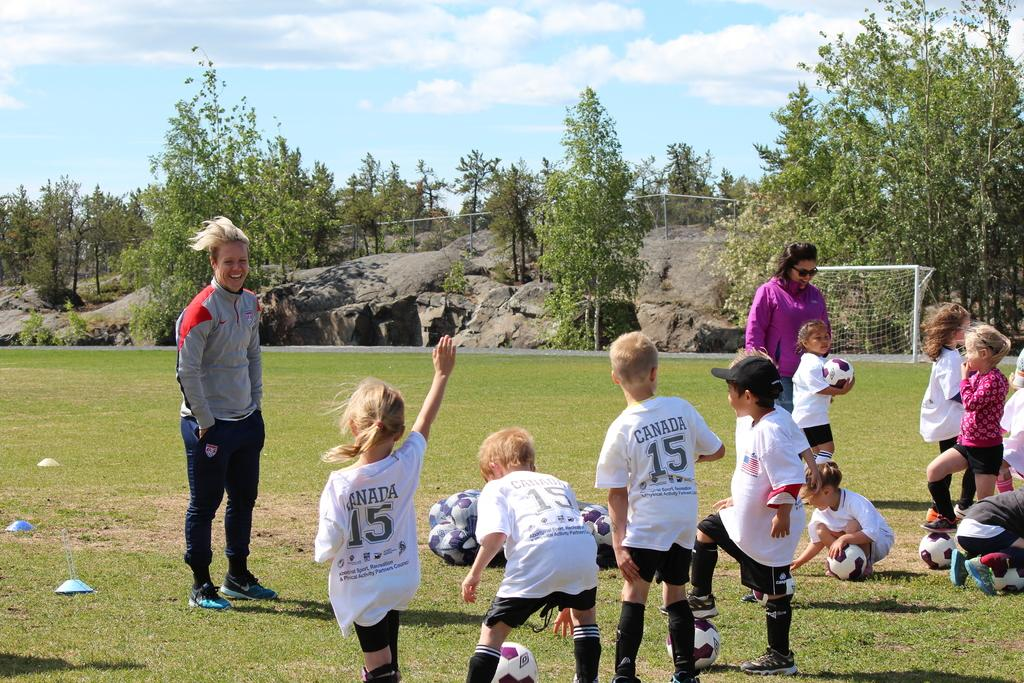How many people are in the group visible in the image? There is a group of persons in the image, but the exact number cannot be determined from the provided facts. What sporting equipment is present in the image? There are footballs and a goal post visible in the image. What type of natural feature can be seen in the image? There are rocks and a group of trees visible in the image. What is visible at the top of the image? The sky is visible at the top of the image. What type of jelly is being spread on the sidewalk in the image? There is no jelly or sidewalk present in the image. How many trucks are visible in the image? There are no trucks visible in the image. 